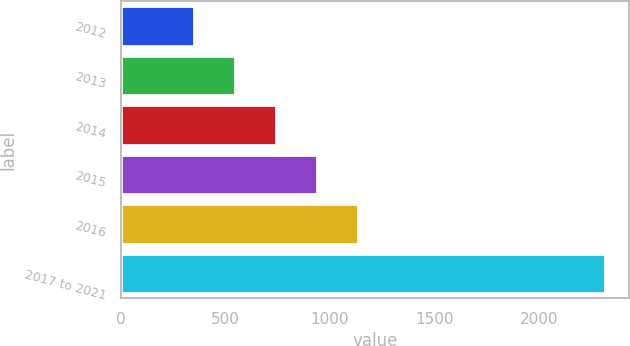<chart> <loc_0><loc_0><loc_500><loc_500><bar_chart><fcel>2012<fcel>2013<fcel>2014<fcel>2015<fcel>2016<fcel>2017 to 2021<nl><fcel>349<fcel>545.6<fcel>742.2<fcel>938.8<fcel>1135.4<fcel>2315<nl></chart> 